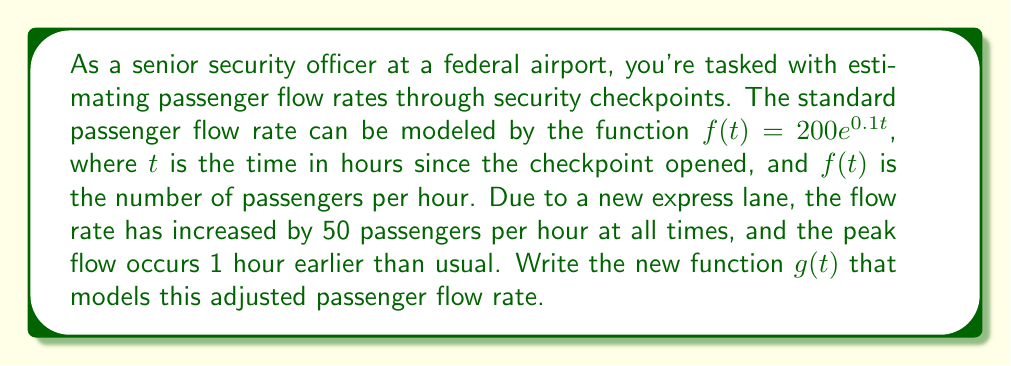Give your solution to this math problem. To solve this problem, we need to apply both a vertical and horizontal shift to the original function $f(t) = 200e^{0.1t}$.

1. Vertical shift:
   The flow rate has increased by 50 passengers per hour at all times. This means we need to add 50 to the function:
   $f(t) + 50$

2. Horizontal shift:
   The peak flow occurs 1 hour earlier than usual. This means we need to shift the function 1 unit to the left on the t-axis. To shift a function h units to the left, we replace t with (t + h):
   $f(t + 1)$

3. Combining the shifts:
   We apply both shifts to get our new function $g(t)$:
   $g(t) = f(t + 1) + 50$

4. Substituting the original function:
   $g(t) = 200e^{0.1(t + 1)} + 50$

5. Simplify:
   $g(t) = 200e^{0.1t} \cdot e^{0.1} + 50$
   $g(t) = 200e^{0.1t} \cdot 1.1052 + 50$
   $g(t) = 221.04e^{0.1t} + 50$

Therefore, the new function modeling the adjusted passenger flow rate is $g(t) = 221.04e^{0.1t} + 50$.
Answer: $g(t) = 221.04e^{0.1t} + 50$ 